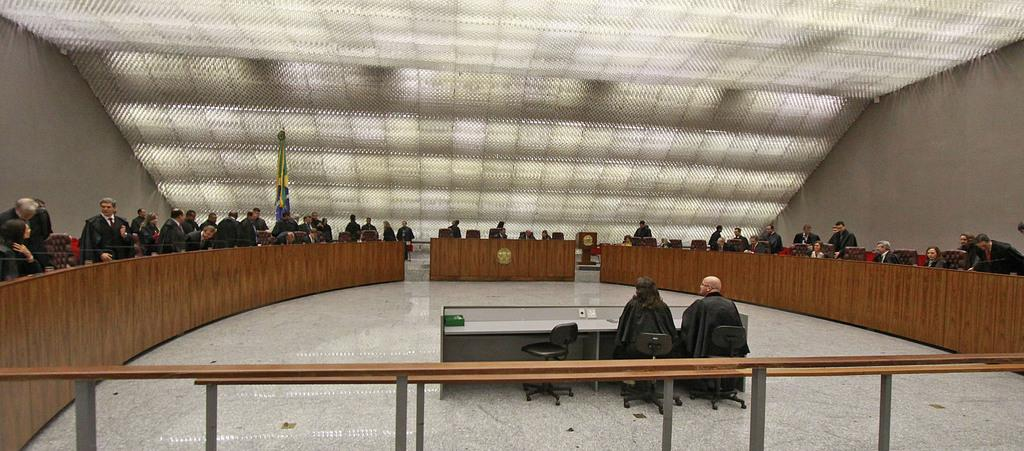What type of location is depicted in the image? The image shows the inside view of a building. Can you describe the people in the image? There are groups of people in the image. What can be seen on the floor in the image? There are tables on the floor in the image. What is visible in the background of the image? There is a flag visible in the background of the image. What is above the people and tables in the image? There is a ceiling in the image. How many rabbits are present in the image? There are no rabbits present in the image. What type of army is depicted in the image? There is no army depicted in the image. 